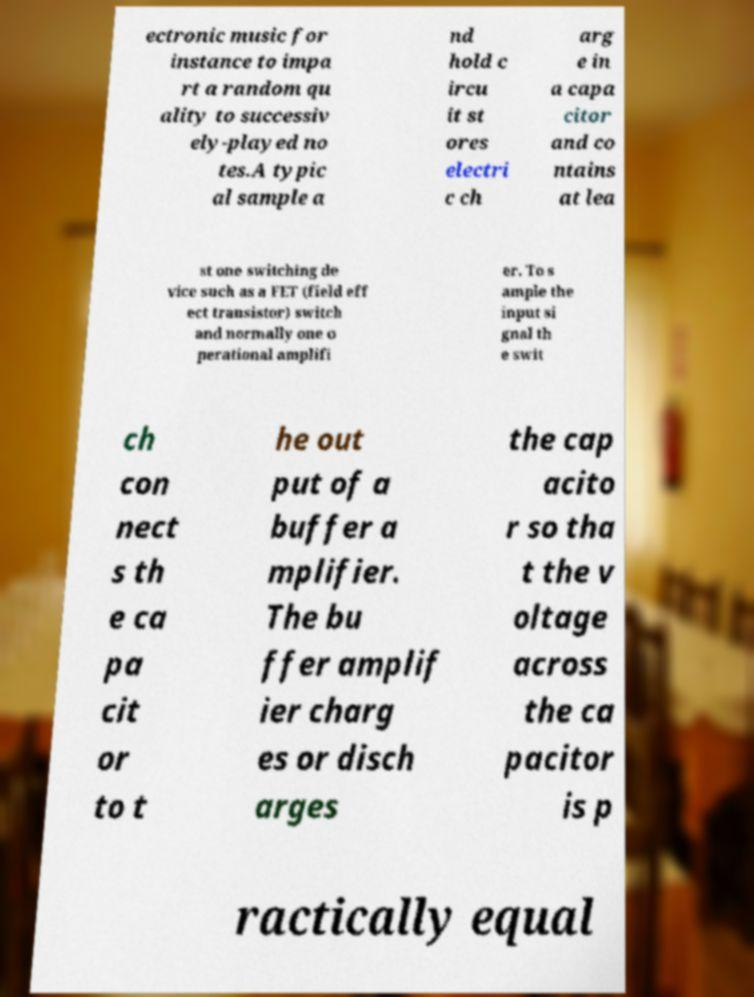I need the written content from this picture converted into text. Can you do that? ectronic music for instance to impa rt a random qu ality to successiv ely-played no tes.A typic al sample a nd hold c ircu it st ores electri c ch arg e in a capa citor and co ntains at lea st one switching de vice such as a FET (field eff ect transistor) switch and normally one o perational amplifi er. To s ample the input si gnal th e swit ch con nect s th e ca pa cit or to t he out put of a buffer a mplifier. The bu ffer amplif ier charg es or disch arges the cap acito r so tha t the v oltage across the ca pacitor is p ractically equal 